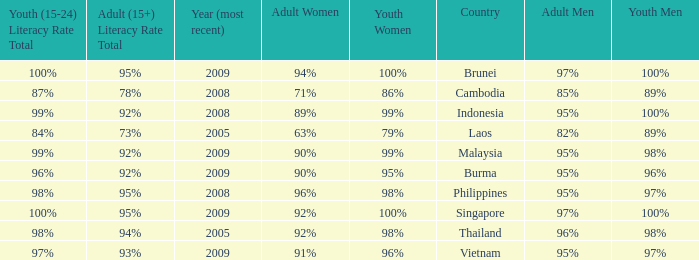Which country has a Youth (15-24) Literacy Rate Total of 100% and has an Adult Women Literacy rate of 92%? Singapore. 